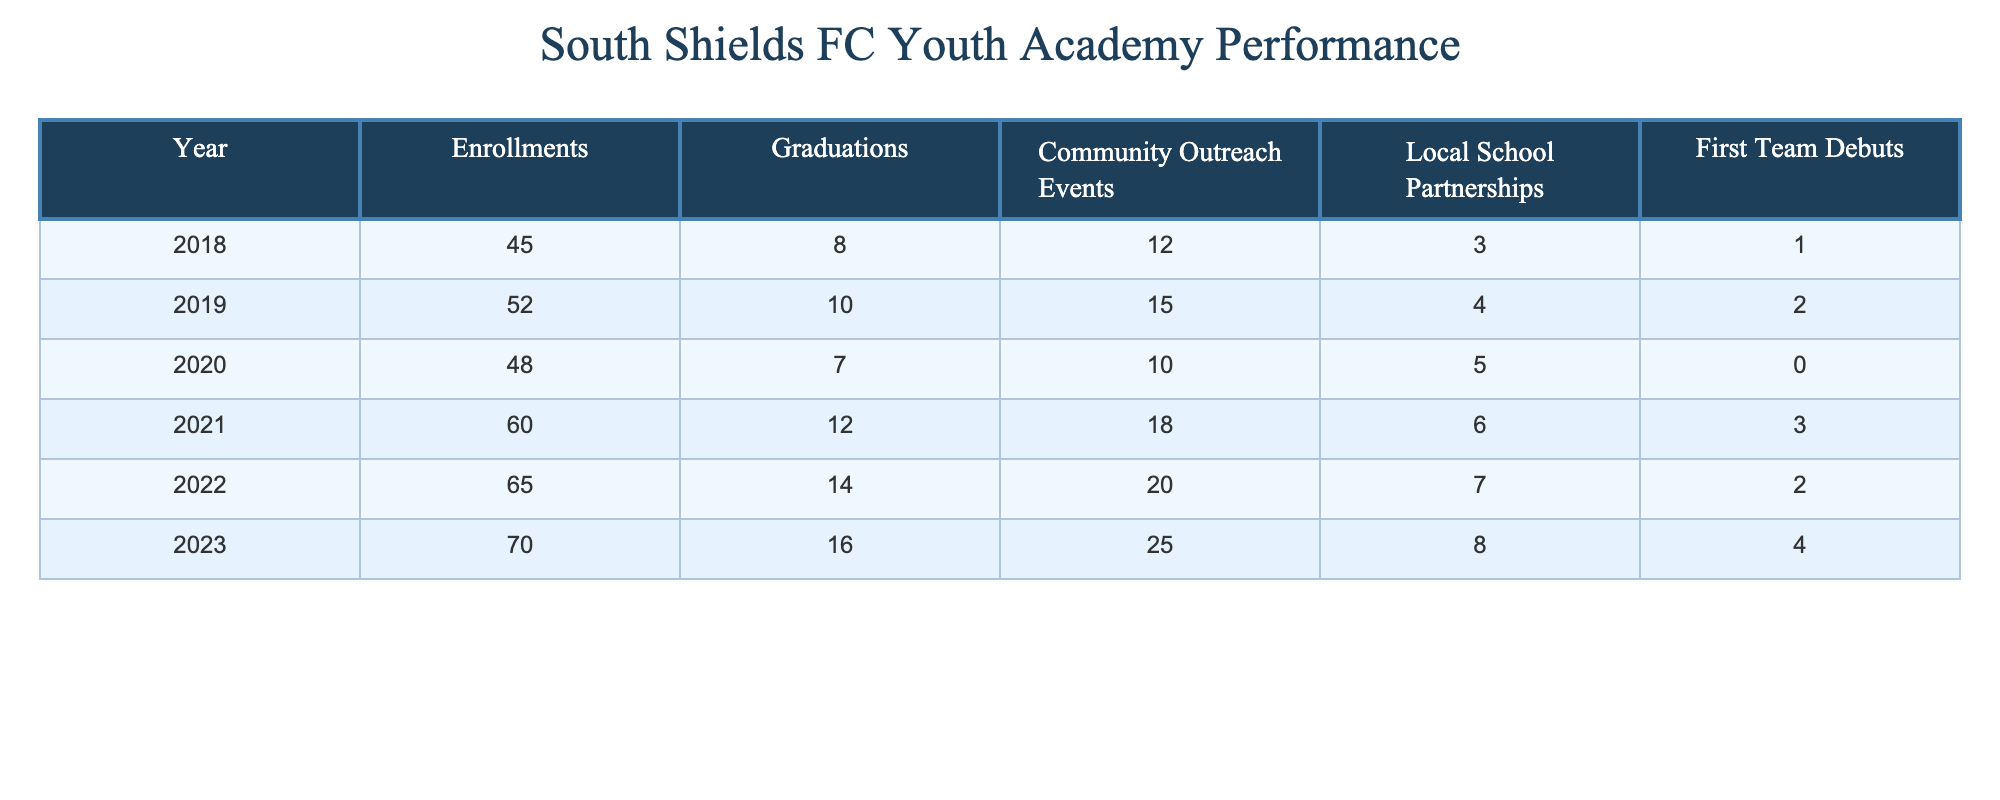What was the highest enrollment in the youth academy? Looking at the 'Enrollments' column, the highest value is 70 in the year 2023.
Answer: 70 What is the total number of graduations from 2018 to 2023? The total graduations can be calculated by adding the values: 8 + 10 + 7 + 12 + 14 + 16 = 67.
Answer: 67 How many community outreach events were held in 2021? Referring to the 'Community Outreach Events' column for the year 2021, the value is 18.
Answer: 18 What was the increase in enrollments from 2020 to 2022? The enrollment for 2020 is 48 and for 2022 is 65. The increase is 65 - 48 = 17.
Answer: 17 Is it true that the number of first team debuts remained the same from 2019 to 2020? In 2019, there were 2 debuts and in 2020, there were 0 debuts. Since these values are not the same, the statement is false.
Answer: False What is the average number of graduations per year from 2018 to 2023? The total graduations from 2018 to 2023 is 67. There are 6 years, so the average is 67 / 6 ≈ 11.17.
Answer: Approximately 11.17 What year had the largest number of first team debuts, and how many were there? The largest number of first team debuts occurred in 2021 with a value of 3.
Answer: 3 in 2021 By how much did the number of local school partnerships increase from 2018 to 2023? The partnerships in 2018 were 3 and in 2023 were 8. The increase is 8 - 3 = 5.
Answer: 5 What percentage of enrolled youth graduated in 2022? In 2022, there were 65 enrollments and 14 graduations, so the percentage is (14 / 65) * 100 ≈ 21.54%.
Answer: Approximately 21.54% Was there a year when the number of graduations was less than 10? Yes, both 2018 (8 graduations) and 2020 (7 graduations) had fewer than 10 graduations.
Answer: Yes 